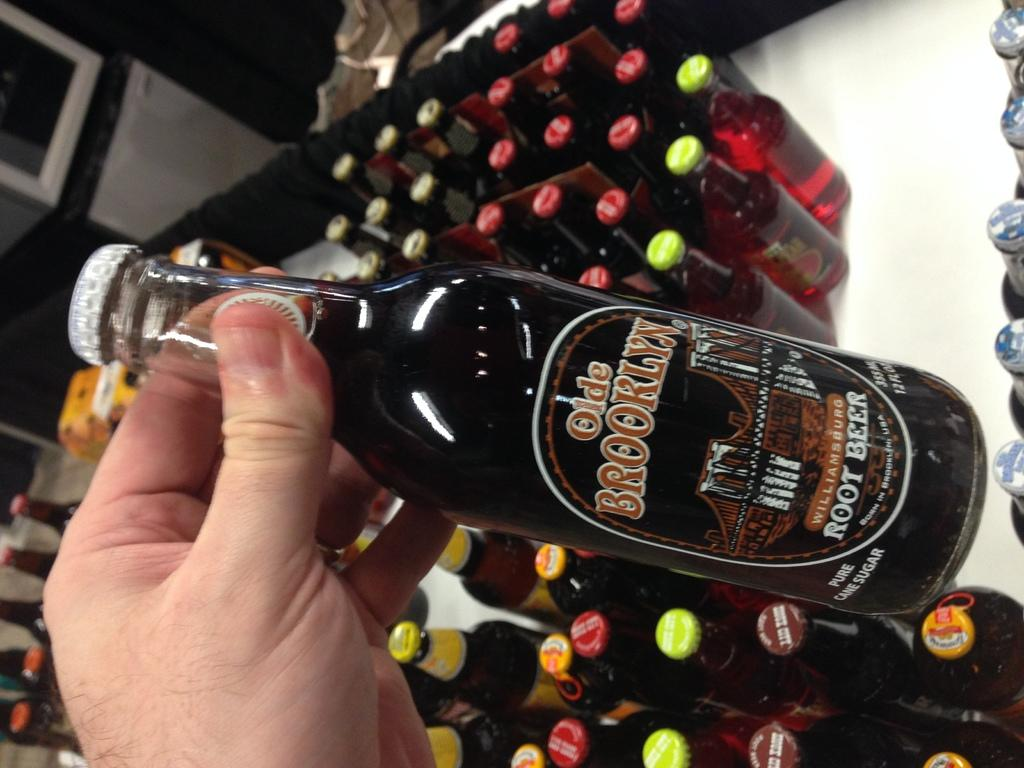<image>
Give a short and clear explanation of the subsequent image. person holding a dark beer bottle titled Olde Brooklyn. 